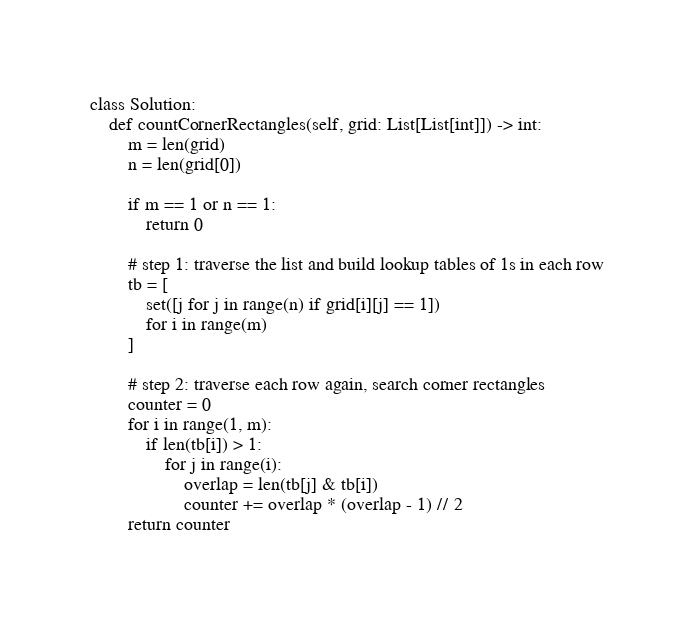Convert code to text. <code><loc_0><loc_0><loc_500><loc_500><_Python_>class Solution:
    def countCornerRectangles(self, grid: List[List[int]]) -> int:
        m = len(grid)
        n = len(grid[0])
        
        if m == 1 or n == 1:
            return 0
        
        # step 1: traverse the list and build lookup tables of 1s in each row
        tb = [
            set([j for j in range(n) if grid[i][j] == 1])
            for i in range(m)
        ]
        
        # step 2: traverse each row again, search corner rectangles
        counter = 0
        for i in range(1, m):
            if len(tb[i]) > 1:
                for j in range(i):
                    overlap = len(tb[j] & tb[i])
                    counter += overlap * (overlap - 1) // 2
        return counter
    </code> 